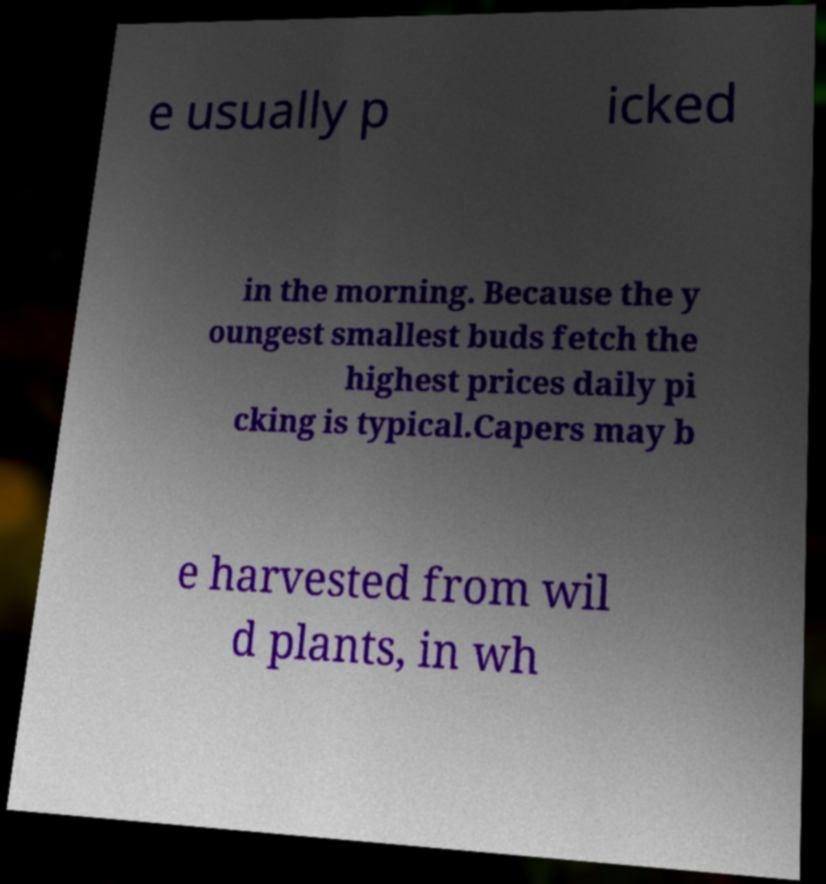What messages or text are displayed in this image? I need them in a readable, typed format. e usually p icked in the morning. Because the y oungest smallest buds fetch the highest prices daily pi cking is typical.Capers may b e harvested from wil d plants, in wh 